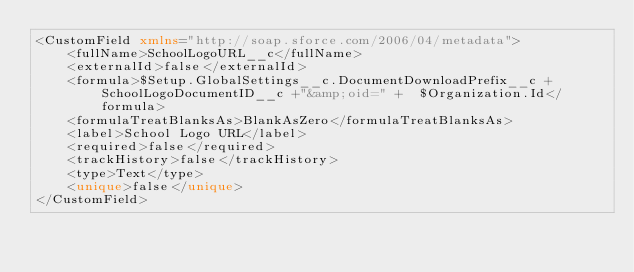<code> <loc_0><loc_0><loc_500><loc_500><_XML_><CustomField xmlns="http://soap.sforce.com/2006/04/metadata">
    <fullName>SchoolLogoURL__c</fullName>
    <externalId>false</externalId>
    <formula>$Setup.GlobalSettings__c.DocumentDownloadPrefix__c + SchoolLogoDocumentID__c +"&amp;oid=" +  $Organization.Id</formula>
    <formulaTreatBlanksAs>BlankAsZero</formulaTreatBlanksAs>
    <label>School Logo URL</label>
    <required>false</required>
    <trackHistory>false</trackHistory>
    <type>Text</type>
    <unique>false</unique>
</CustomField>
</code> 